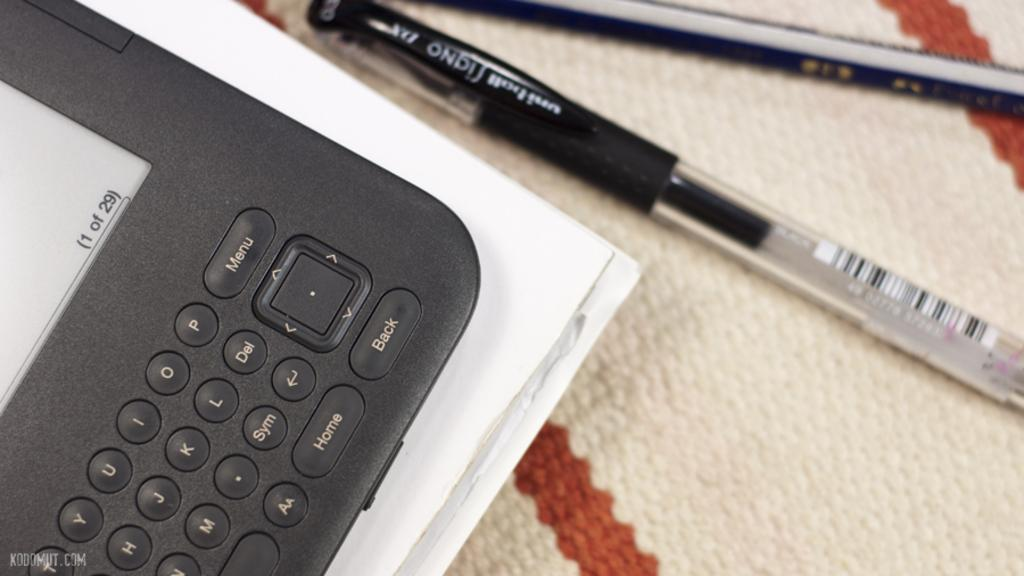Provide a one-sentence caption for the provided image. The edge of a tablet is on a cloth with a Signa ink pen to it's right. 